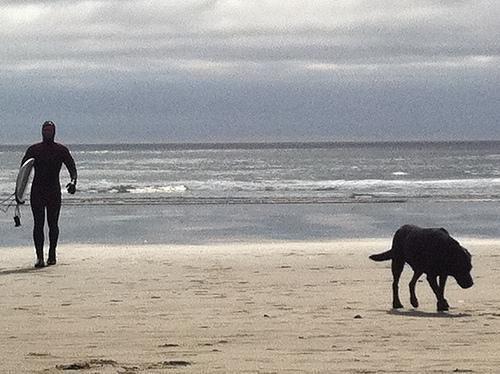How many dogs in the beach?
Give a very brief answer. 1. 